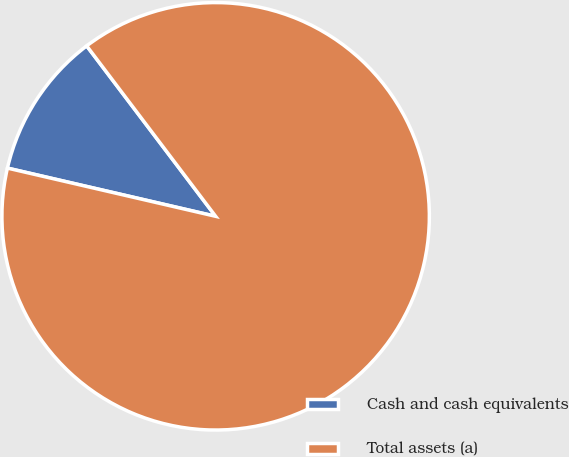<chart> <loc_0><loc_0><loc_500><loc_500><pie_chart><fcel>Cash and cash equivalents<fcel>Total assets (a)<nl><fcel>11.07%<fcel>88.93%<nl></chart> 